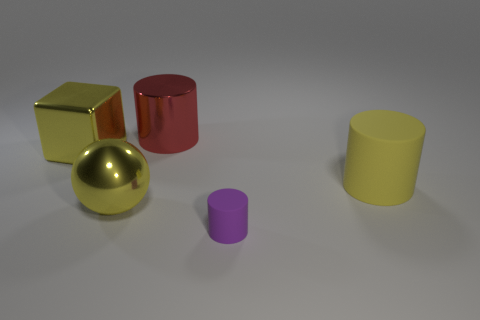There is a matte object that is in front of the large yellow ball; is its shape the same as the red metal thing?
Provide a succinct answer. Yes. There is a rubber cylinder in front of the yellow object that is on the right side of the big red metal cylinder; what is its size?
Provide a short and direct response. Small. There is a cylinder that is the same material as the tiny purple thing; what is its color?
Your response must be concise. Yellow. What number of yellow matte cylinders are the same size as the sphere?
Offer a terse response. 1. What number of yellow objects are big cubes or big shiny spheres?
Offer a terse response. 2. How many objects are large balls or big objects left of the tiny purple cylinder?
Provide a succinct answer. 3. There is a big cylinder behind the big yellow block; what is it made of?
Provide a short and direct response. Metal. There is another rubber object that is the same size as the red thing; what is its shape?
Provide a succinct answer. Cylinder. Is there a big gray matte object of the same shape as the red shiny thing?
Provide a short and direct response. No. Are the large red cylinder and the yellow thing that is on the right side of the large red metal thing made of the same material?
Provide a short and direct response. No. 